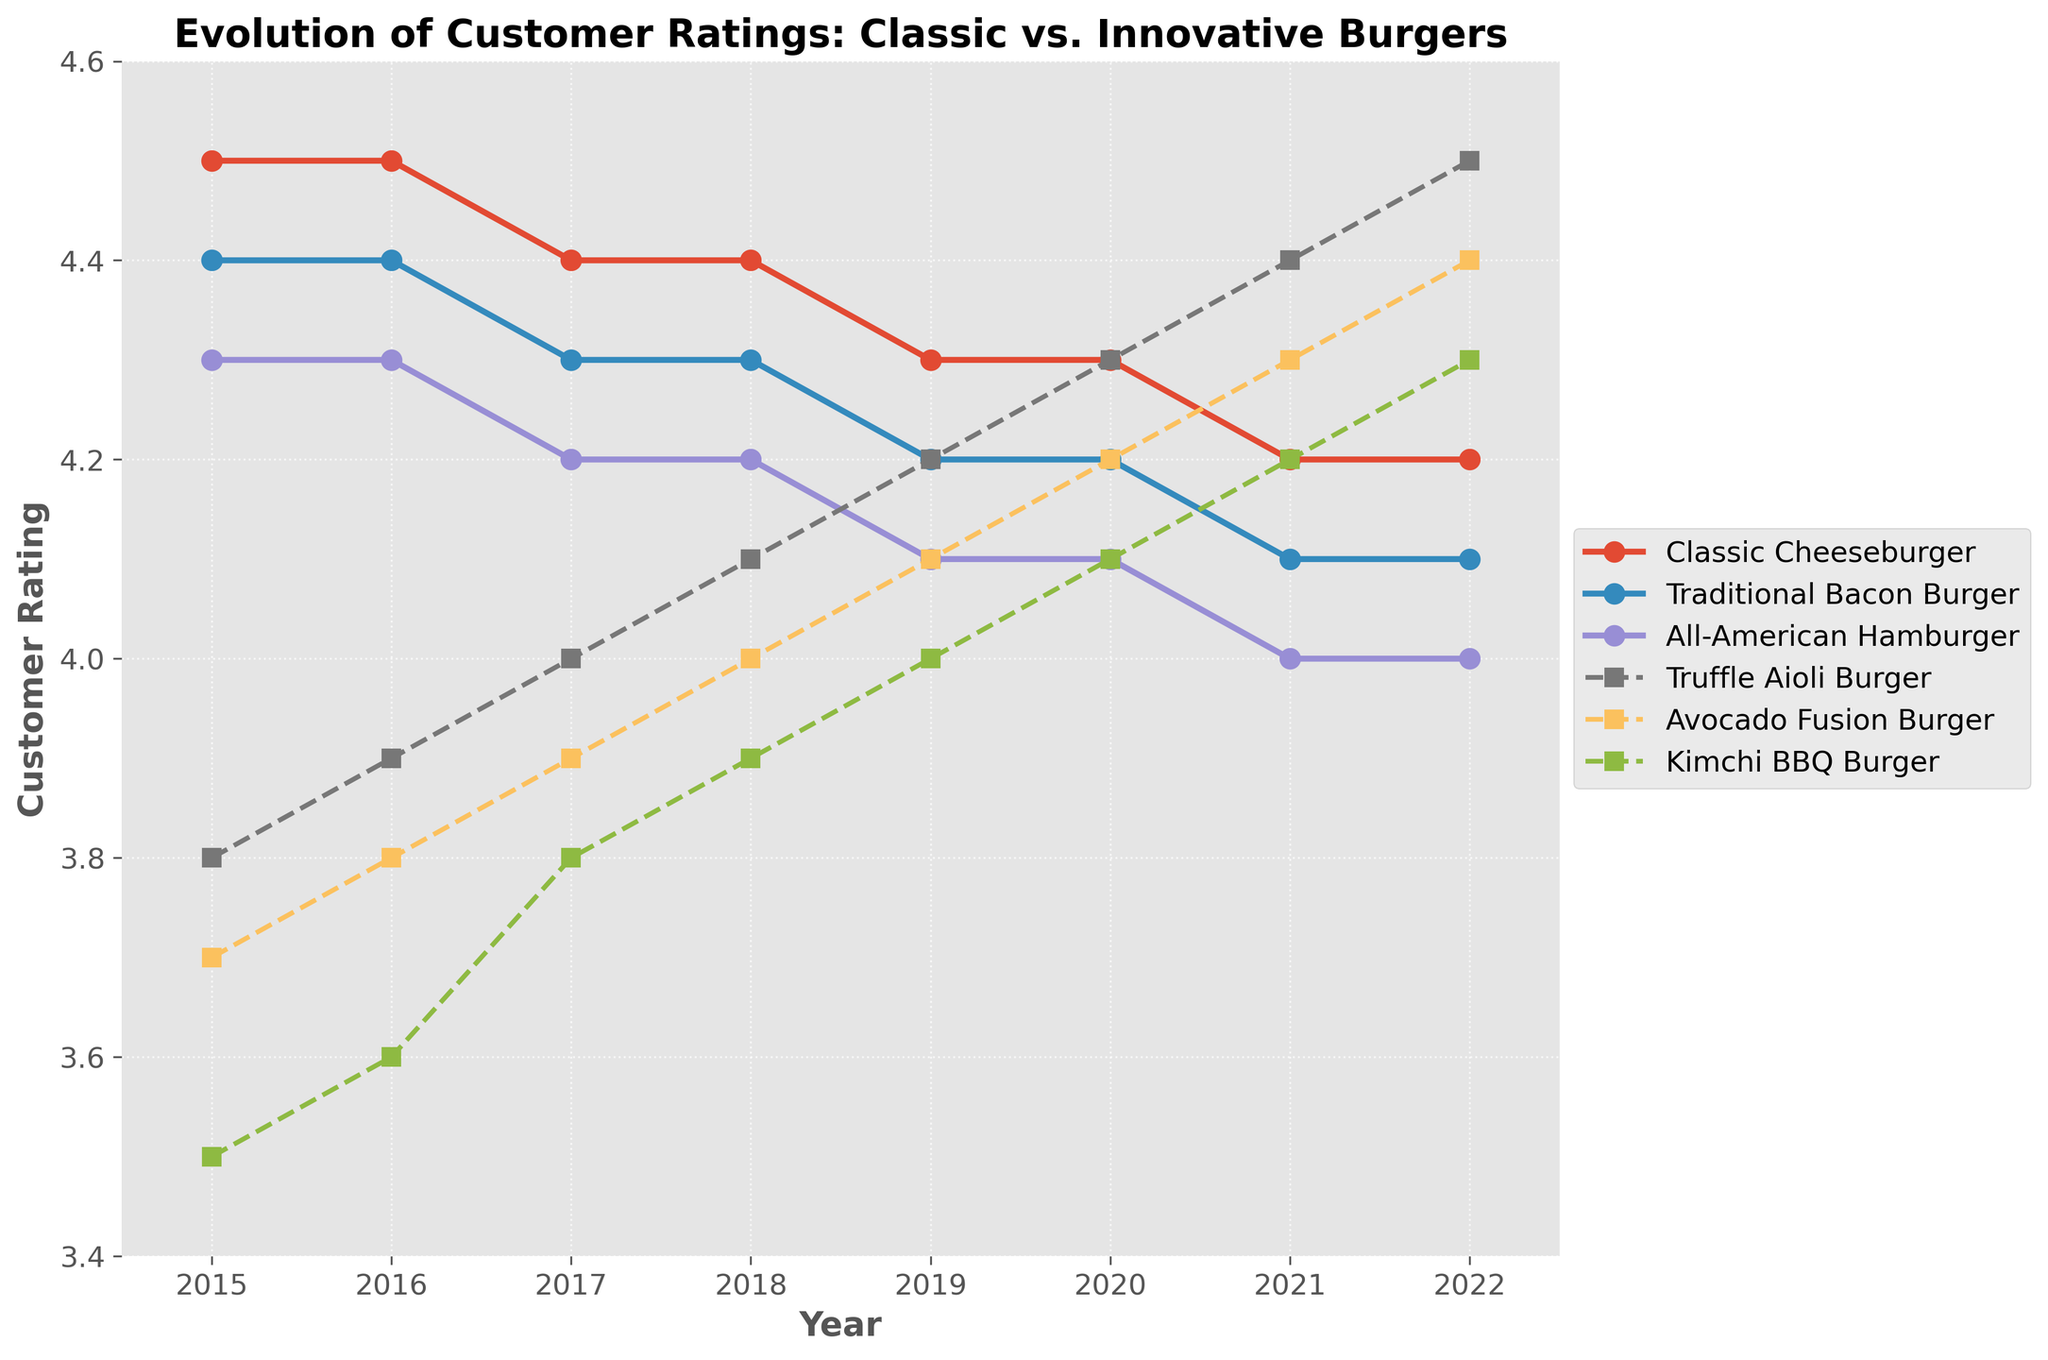What was the customer rating for the "Classic Cheeseburger" in 2021? Look at the line representing the "Classic Cheeseburger" and identify the rating value corresponding to the year 2021. The rating is 4.2.
Answer: 4.2 Did the "Traditional Bacon Burger" have a higher or lower rating in 2020 compared to 2017? Compare the rating values for the "Traditional Bacon Burger" in 2020 and 2017. The rating is the same, both being 4.2.
Answer: Equal Which burger had the most significant increase in customer ratings from 2015 to 2022? Calculate the difference in ratings between 2022 and 2015 for each burger. "Truffle Aioli Burger" increased from 3.8 to 4.5, which is a 0.7 increase, the highest among all.
Answer: Truffle Aioli Burger What is the average rating for the "Avocado Fusion Burger" from 2015 to 2022? Sum up the rating values for "Avocado Fusion Burger" from 2015 to 2022 and divide by the number of years. The sum is 3.7 + 3.8 + 3.9 + 4.0 + 4.1 + 4.2 + 4.3 + 4.4 = 32.4. Average is 32.4/8 = 4.05.
Answer: 4.05 How did the rating of the "Kimchi BBQ Burger" change between 2018 and 2021? Compare the rating values of the "Kimchi BBQ Burger" in 2018 and 2021. It changed from 3.9 to 4.2. The difference is 0.3.
Answer: Increased by 0.3 Among all the burgers, which one had the lowest average rating over the years? Calculate the average rating for each burger across all the years and compare the values. The "Kimchi BBQ Burger" has the lowest average rating (3.5 + 3.6 + 3.8 + 3.9 + 4.0 + 4.1 + 4.2 + 4.3)/8 ≈ 3.92.
Answer: Kimchi BBQ Burger Which year did the "Truffle Aioli Burger" surpass the "All-American Hamburger" in customer ratings? Compare the ratings of the "Truffle Aioli Burger" and "All-American Hamburger" for each year. The "Truffle Aioli Burger" surpassed the "All-American Hamburger" for the first time in 2019.
Answer: 2019 Were the ratings of "Classic Cheeseburger" higher than "Traditional Bacon Burger" every year? Compare the yearly ratings of both burgers. The "Classic Cheeseburger" had higher ratings each year from 2015 to 2022.
Answer: Yes What was the trend in ratings for "All-American Hamburger" from 2015 to 2022? Observe the line representing "All-American Hamburger" from 2015 to 2022. The ratings gradually decreased from 4.3 to 4.0 for the "All-American Hamburger".
Answer: Decreasing Compare the visual representation of line styles between classic and innovative burgers. What does this indicate? Classic burgers use solid lines with circle markers, while innovative burgers use dashed lines with square markers. This indicates a visual distinction between the two categories for clarity in the chart.
Answer: Solid lines for classic, dashed lines for innovative 